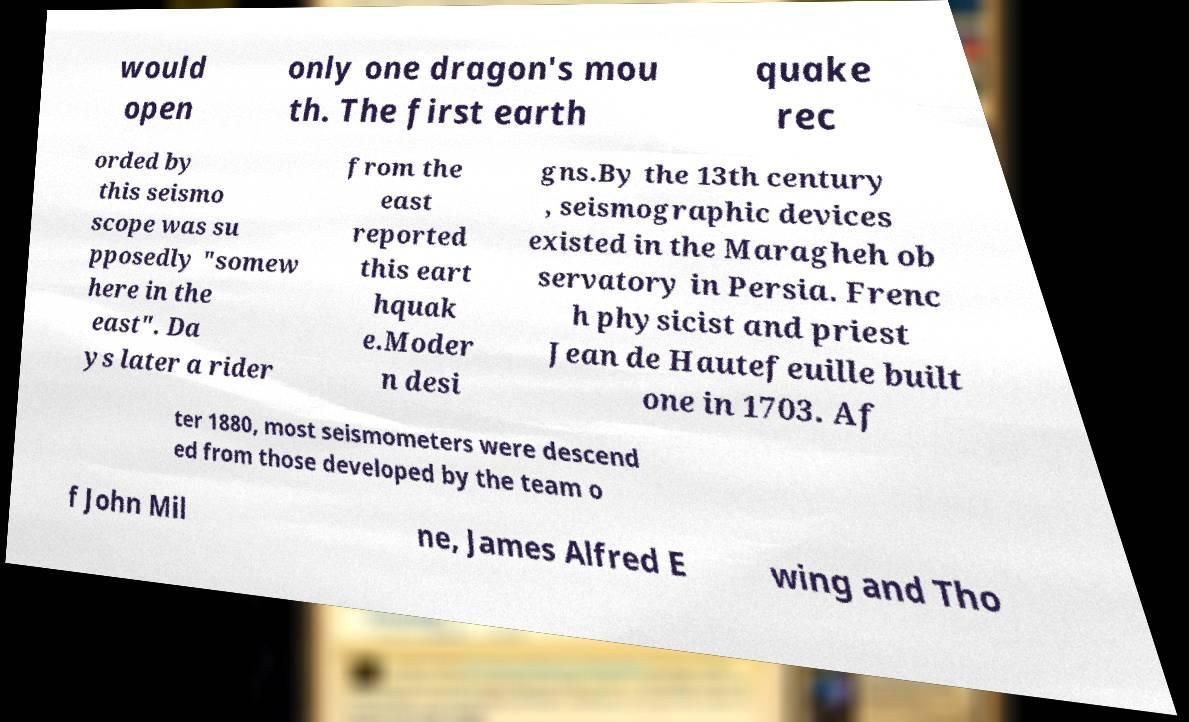Could you extract and type out the text from this image? would open only one dragon's mou th. The first earth quake rec orded by this seismo scope was su pposedly "somew here in the east". Da ys later a rider from the east reported this eart hquak e.Moder n desi gns.By the 13th century , seismographic devices existed in the Maragheh ob servatory in Persia. Frenc h physicist and priest Jean de Hautefeuille built one in 1703. Af ter 1880, most seismometers were descend ed from those developed by the team o f John Mil ne, James Alfred E wing and Tho 